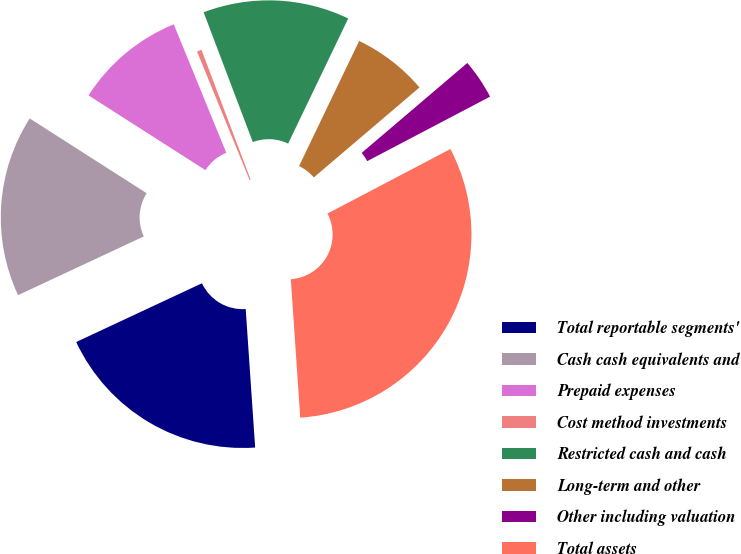Convert chart to OTSL. <chart><loc_0><loc_0><loc_500><loc_500><pie_chart><fcel>Total reportable segments'<fcel>Cash cash equivalents and<fcel>Prepaid expenses<fcel>Cost method investments<fcel>Restricted cash and cash<fcel>Long-term and other<fcel>Other including valuation<fcel>Total assets<nl><fcel>19.13%<fcel>16.01%<fcel>9.77%<fcel>0.41%<fcel>12.89%<fcel>6.65%<fcel>3.53%<fcel>31.61%<nl></chart> 